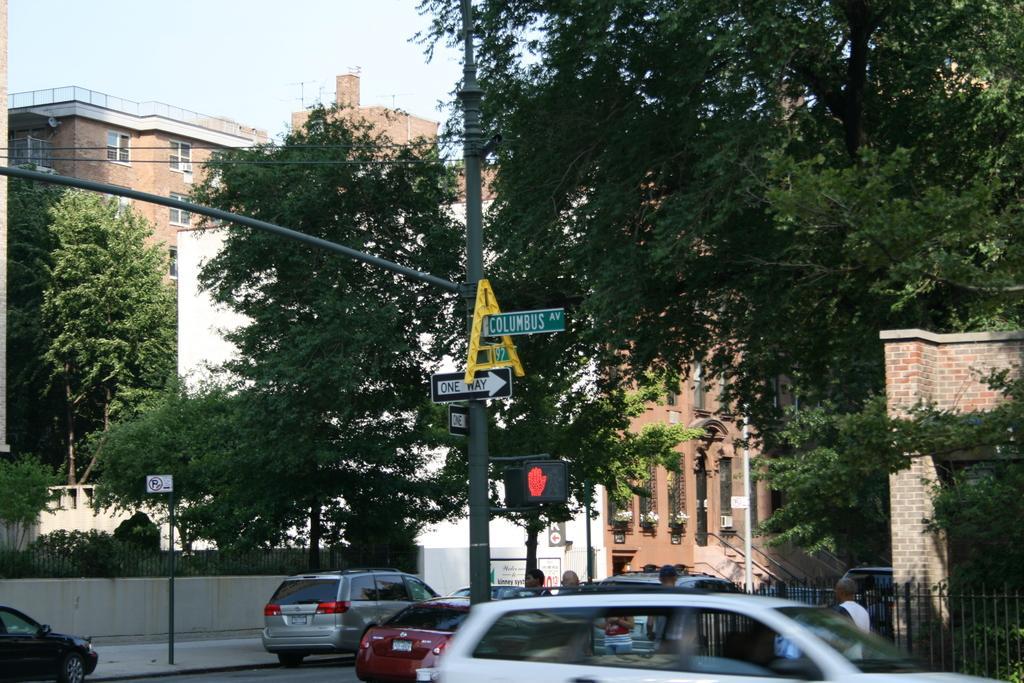Describe this image in one or two sentences. In this image, we can see vehicles and people on the road. In the background, there are poles along with wires and we can see boards, buildings and trees and we can see a grille. At the top, there is sky. 